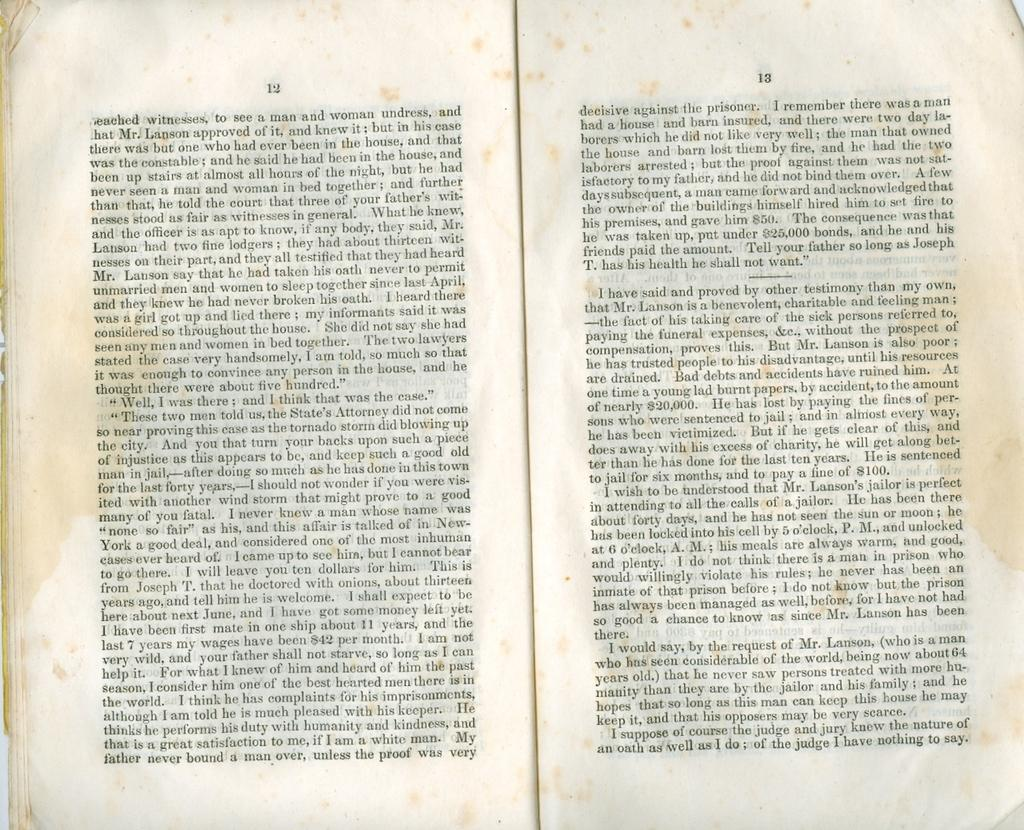Provide a one-sentence caption for the provided image. Two pages of a book that feature characters such as Mr. Lanson. 